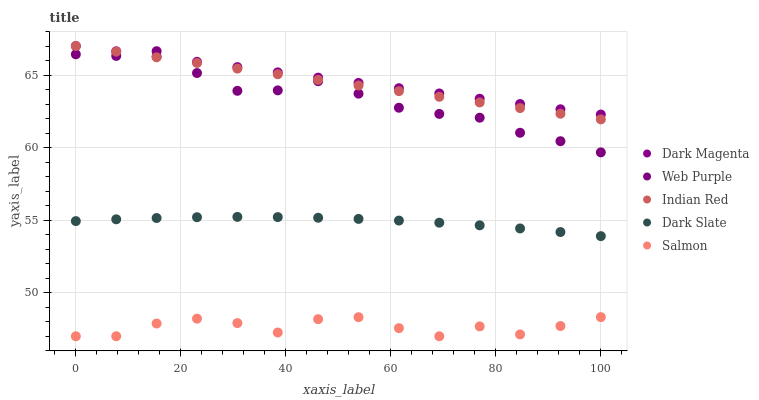Does Salmon have the minimum area under the curve?
Answer yes or no. Yes. Does Dark Magenta have the maximum area under the curve?
Answer yes or no. Yes. Does Web Purple have the minimum area under the curve?
Answer yes or no. No. Does Web Purple have the maximum area under the curve?
Answer yes or no. No. Is Indian Red the smoothest?
Answer yes or no. Yes. Is Salmon the roughest?
Answer yes or no. Yes. Is Web Purple the smoothest?
Answer yes or no. No. Is Web Purple the roughest?
Answer yes or no. No. Does Salmon have the lowest value?
Answer yes or no. Yes. Does Web Purple have the lowest value?
Answer yes or no. No. Does Indian Red have the highest value?
Answer yes or no. Yes. Does Web Purple have the highest value?
Answer yes or no. No. Is Dark Slate less than Dark Magenta?
Answer yes or no. Yes. Is Web Purple greater than Dark Slate?
Answer yes or no. Yes. Does Web Purple intersect Indian Red?
Answer yes or no. Yes. Is Web Purple less than Indian Red?
Answer yes or no. No. Is Web Purple greater than Indian Red?
Answer yes or no. No. Does Dark Slate intersect Dark Magenta?
Answer yes or no. No. 